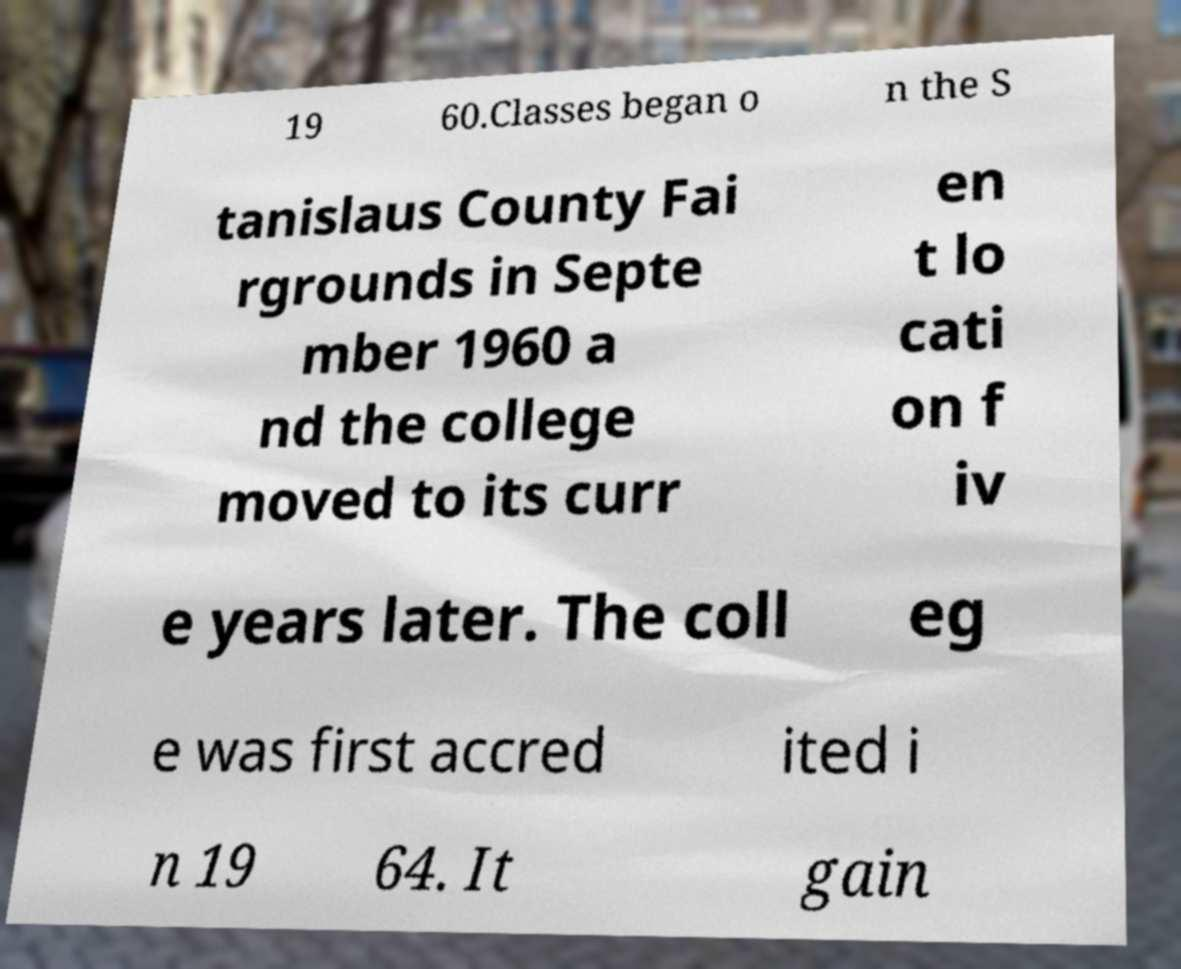Can you accurately transcribe the text from the provided image for me? 19 60.Classes began o n the S tanislaus County Fai rgrounds in Septe mber 1960 a nd the college moved to its curr en t lo cati on f iv e years later. The coll eg e was first accred ited i n 19 64. It gain 